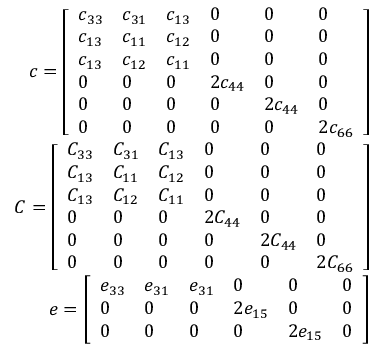Convert formula to latex. <formula><loc_0><loc_0><loc_500><loc_500>\begin{array} { r } { c = \left [ \begin{array} { l l l l l l } { c _ { 3 3 } } & { c _ { 3 1 } } & { c _ { 1 3 } } & { 0 } & { 0 } & { 0 } \\ { c _ { 1 3 } } & { c _ { 1 1 } } & { c _ { 1 2 } } & { 0 } & { 0 } & { 0 } \\ { c _ { 1 3 } } & { c _ { 1 2 } } & { c _ { 1 1 } } & { 0 } & { 0 } & { 0 } \\ { 0 } & { 0 } & { 0 } & { 2 c _ { 4 4 } } & { 0 } & { 0 } \\ { 0 } & { 0 } & { 0 } & { 0 } & { 2 c _ { 4 4 } } & { 0 } \\ { 0 } & { 0 } & { 0 } & { 0 } & { 0 } & { 2 c _ { 6 6 } } \end{array} \right ] } \\ { C = \left [ \begin{array} { l l l l l l } { C _ { 3 3 } } & { C _ { 3 1 } } & { C _ { 1 3 } } & { 0 } & { 0 } & { 0 } \\ { C _ { 1 3 } } & { C _ { 1 1 } } & { C _ { 1 2 } } & { 0 } & { 0 } & { 0 } \\ { C _ { 1 3 } } & { C _ { 1 2 } } & { C _ { 1 1 } } & { 0 } & { 0 } & { 0 } \\ { 0 } & { 0 } & { 0 } & { 2 C _ { 4 4 } } & { 0 } & { 0 } \\ { 0 } & { 0 } & { 0 } & { 0 } & { 2 C _ { 4 4 } } & { 0 } \\ { 0 } & { 0 } & { 0 } & { 0 } & { 0 } & { 2 C _ { 6 6 } } \end{array} \right ] } \\ { e = \left [ \begin{array} { l l l l l l } { e _ { 3 3 } } & { e _ { 3 1 } } & { e _ { 3 1 } } & { 0 } & { 0 } & { 0 } \\ { 0 } & { 0 } & { 0 } & { 2 e _ { 1 5 } } & { 0 } & { 0 } \\ { 0 } & { 0 } & { 0 } & { 0 } & { 2 e _ { 1 5 } } & { 0 } \end{array} \right ] } \end{array}</formula> 